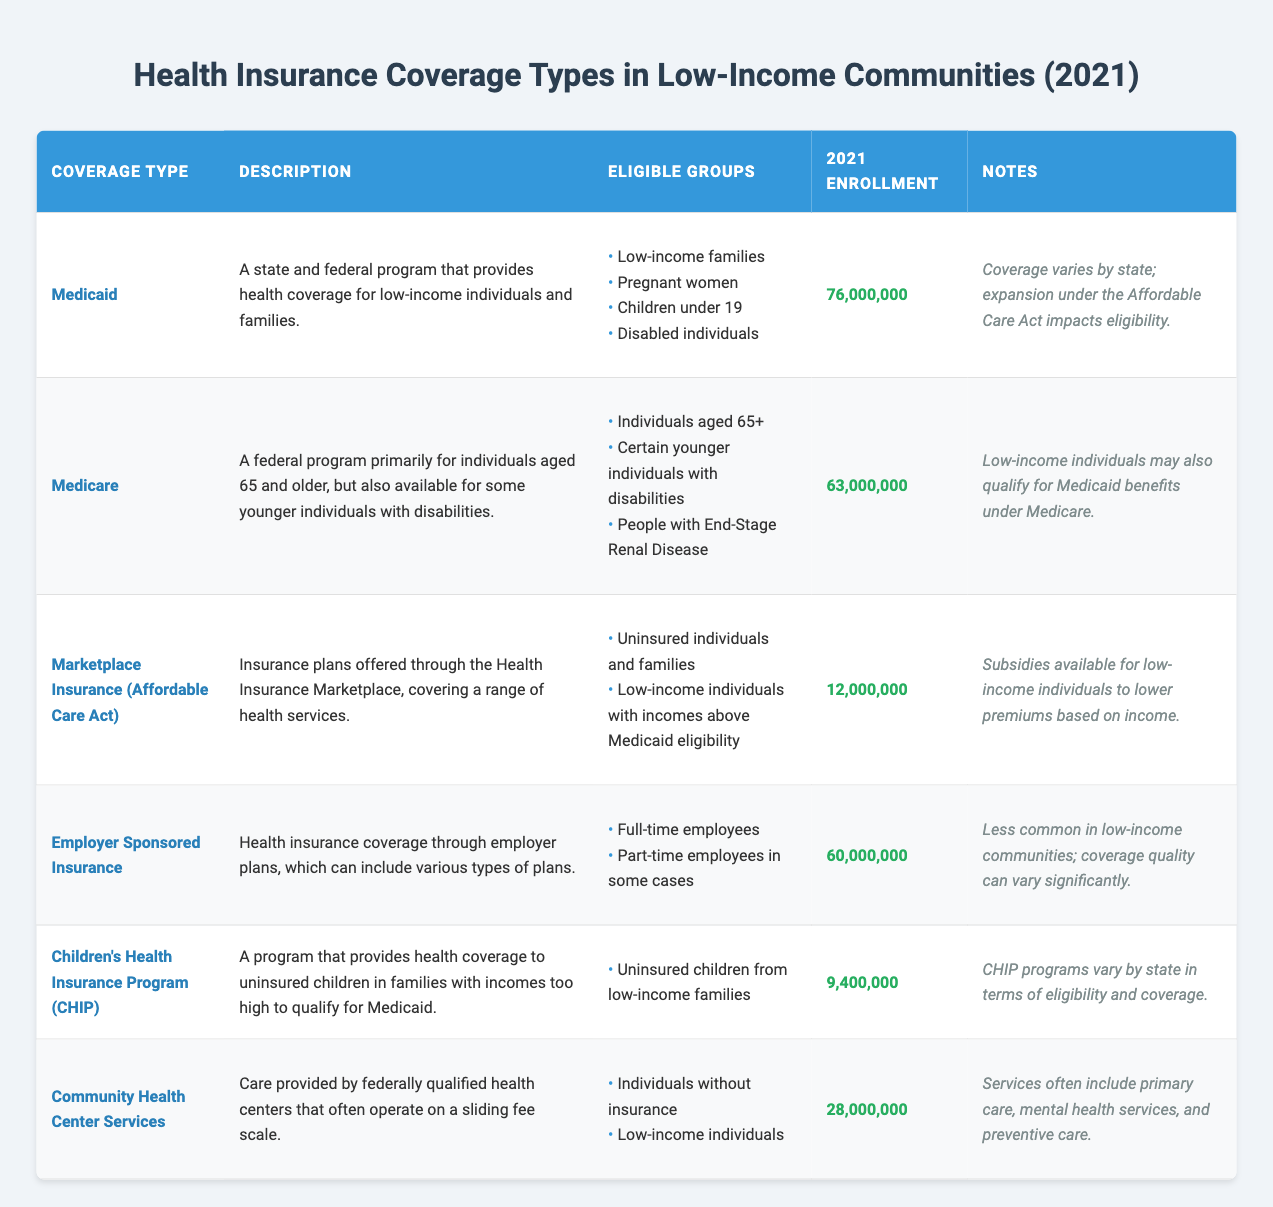What is the enrollment number for Medicaid in 2021? The table directly lists the enrollment number for Medicaid under the "2021 Enrollment" column as 76,000,000.
Answer: 76,000,000 How many individuals were enrolled in Marketplace Insurance in 2021? The table provides the enrollment figure for Marketplace Insurance in the "2021 Enrollment" column, which is 12,000,000.
Answer: 12,000,000 Which health insurance program has the highest enrollment? By comparing the "2021 Enrollment" figures for all the programs listed, Medicaid has the highest enrollment number at 76,000,000.
Answer: Medicaid What percentage of the total enrollment (Medicaid + Medicare + Marketplace Insurance + Employer Sponsored Insurance + CHIP + Community Health Center Services) does Medicaid represent? First, calculate the total enrollment: (76,000,000 + 63,000,000 + 12,000,000 + 60,000,000 + 9,400,000 + 28,000,000) = 248,400,000. Then, find the percentage that Medicaid represents: (76,000,000 / 248,400,000) * 100 ≈ 30.6%.
Answer: 30.6% Is it true that CHIP enrollment is higher than Community Health Center Services enrollment? The enrollment numbers are 9,400,000 for CHIP and 28,000,000 for Community Health Center Services. Since 9,400,000 < 28,000,000, the statement is false.
Answer: No How many coverage types are available for uninsured individuals and families? Reviewing the table, both Marketplace Insurance and Community Health Center Services mention eligibility for uninsured individuals and families. This amounts to two coverage types.
Answer: 2 What is the total enrollment for the Employer Sponsored Insurance and Community Health Center Services combined? The enrollment for Employer Sponsored Insurance is 60,000,000 and for Community Health Center Services is 28,000,000. By adding these two figures, 60,000,000 + 28,000,000 = 88,000,000.
Answer: 88,000,000 Do Medicaid and Medicare cover overlapping eligible groups? Yes, both programs provide coverage for low-income individuals. Some eligible groups for Medicaid include low-income families and disabled individuals, while Medicare also provides benefits to low-income individuals who qualify for Medicaid.
Answer: Yes What coverage type serves uninsured children from families with incomes too high to qualify for Medicaid? The table specifies that the Children's Health Insurance Program (CHIP) provides coverage for uninsured children in such scenarios.
Answer: Children's Health Insurance Program (CHIP) 